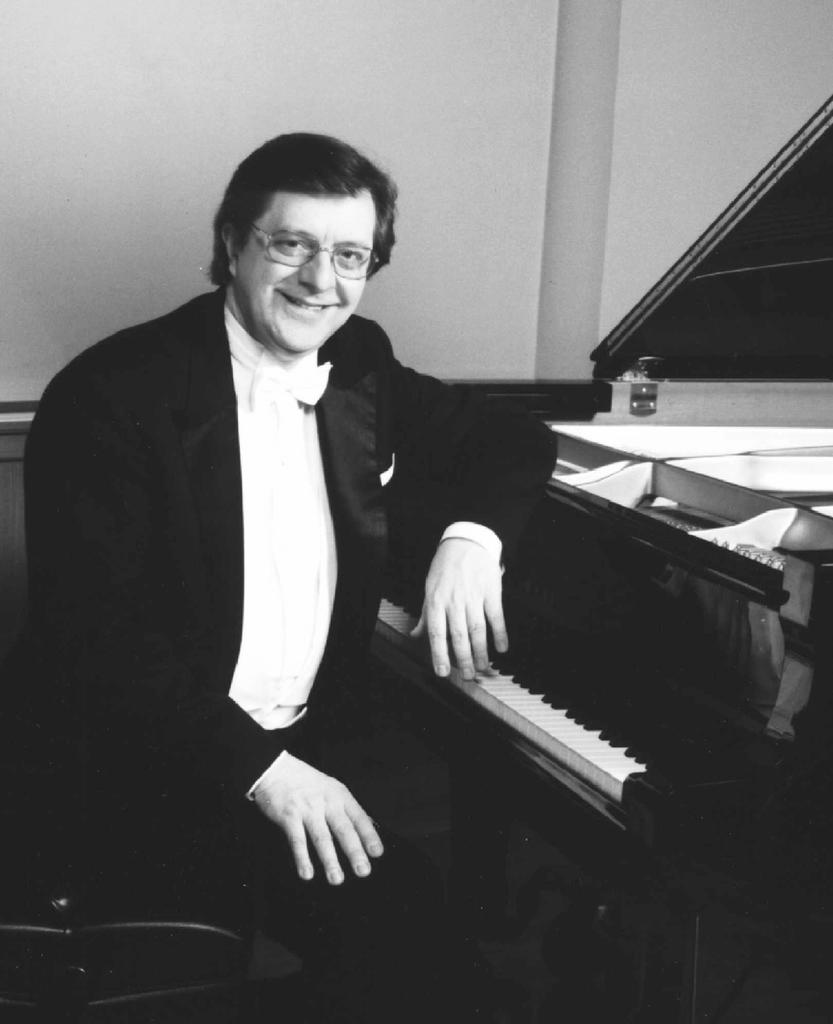What is the person in the image doing? The person is sitting on a chair in the image. What is the person's facial expression? The person is smiling. What object is in front of the person? There is a piano in front of the person. What can be seen in the background of the image? There is a wall in the background of the image. What type of ice can be seen melting on the piano in the image? There is no ice present in the image, and therefore no such activity can be observed. 